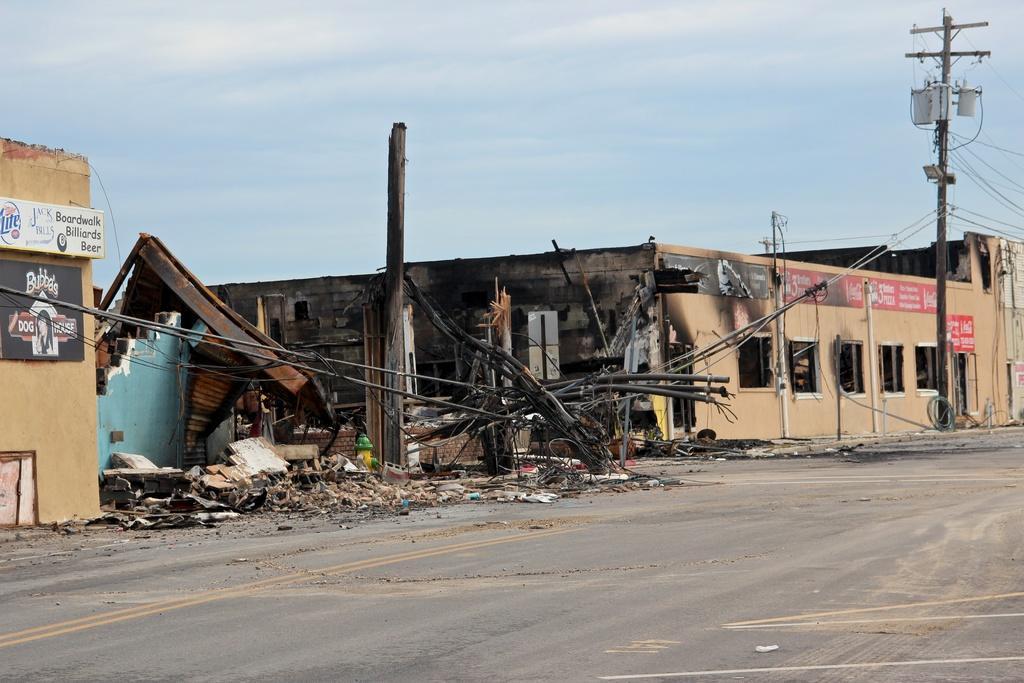Could you give a brief overview of what you see in this image? In this image, we can see some houses, poles, wires, boards with text. We can see the broken wall. We can see the ground with some objects. We can also see the sky with clouds. 